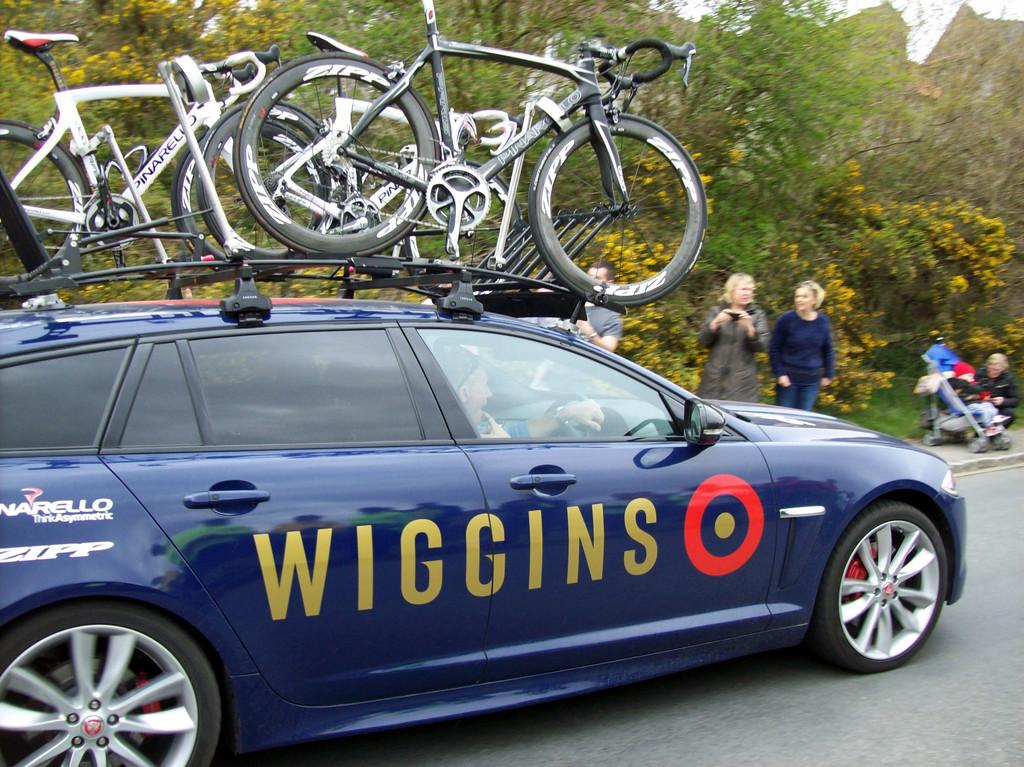What is the main subject of the image? The main subject of the image is a car. What can be seen on the car? Something is written on the car, and there are cycles on it. What is visible in the background of the image? There are people standing and trees in the background of the image. How many socks are hanging from the car in the image? There are no socks present in the image; the car has cycles on it. What type of chain is connecting the trees in the background of the image? There is no chain connecting the trees in the background of the image; only trees and people are visible. 